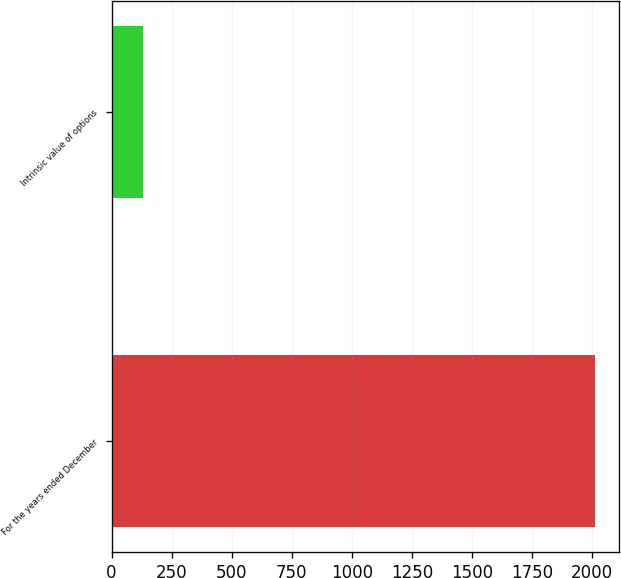<chart> <loc_0><loc_0><loc_500><loc_500><bar_chart><fcel>For the years ended December<fcel>Intrinsic value of options<nl><fcel>2012<fcel>130.2<nl></chart> 